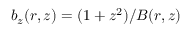<formula> <loc_0><loc_0><loc_500><loc_500>b _ { z } ( r , z ) = ( 1 + z ^ { 2 } ) / B ( r , z )</formula> 